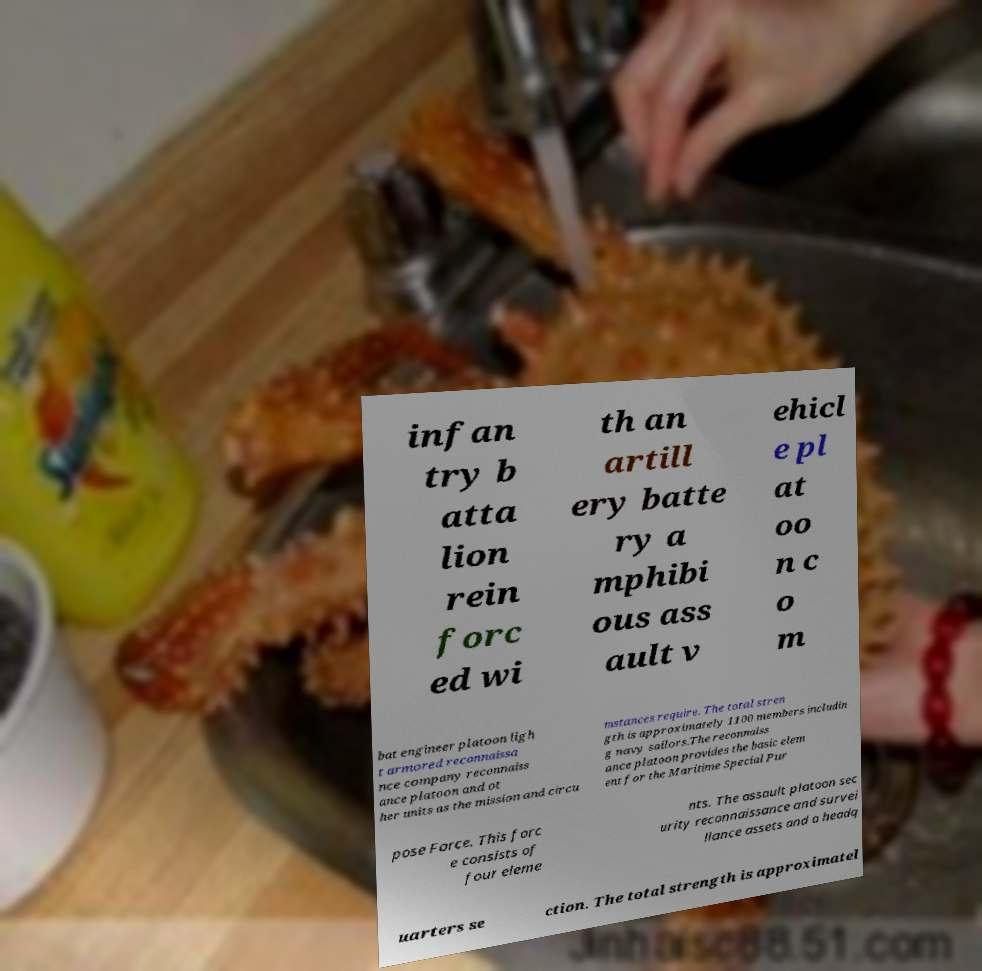What messages or text are displayed in this image? I need them in a readable, typed format. infan try b atta lion rein forc ed wi th an artill ery batte ry a mphibi ous ass ault v ehicl e pl at oo n c o m bat engineer platoon ligh t armored reconnaissa nce company reconnaiss ance platoon and ot her units as the mission and circu mstances require. The total stren gth is approximately 1100 members includin g navy sailors.The reconnaiss ance platoon provides the basic elem ent for the Maritime Special Pur pose Force. This forc e consists of four eleme nts. The assault platoon sec urity reconnaissance and survei llance assets and a headq uarters se ction. The total strength is approximatel 